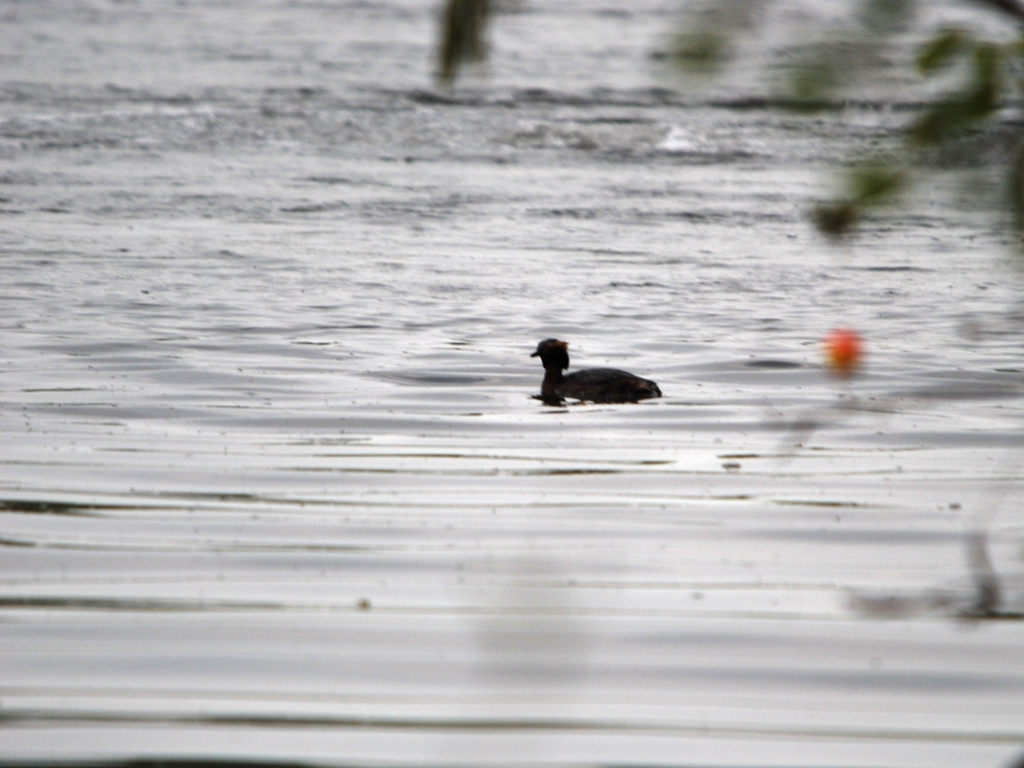What time of day does the photo seem to have been taken? The lighting conditions and the lack of shadows suggest that the photo was likely taken on an overcast day or at a time when the sun was obscured, making it difficult to determine the exact time of day. However, the generally low light levels might imply that it could be around dawn or dusk. What emotion does this image evoke? The image may evoke a sense of tranquility or solitude due to the singular focus on the bird in the vastness of the water. The blurred details and overcast conditions could also contribute to a somewhat melancholic or serene atmosphere. 